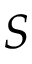<formula> <loc_0><loc_0><loc_500><loc_500>S</formula> 